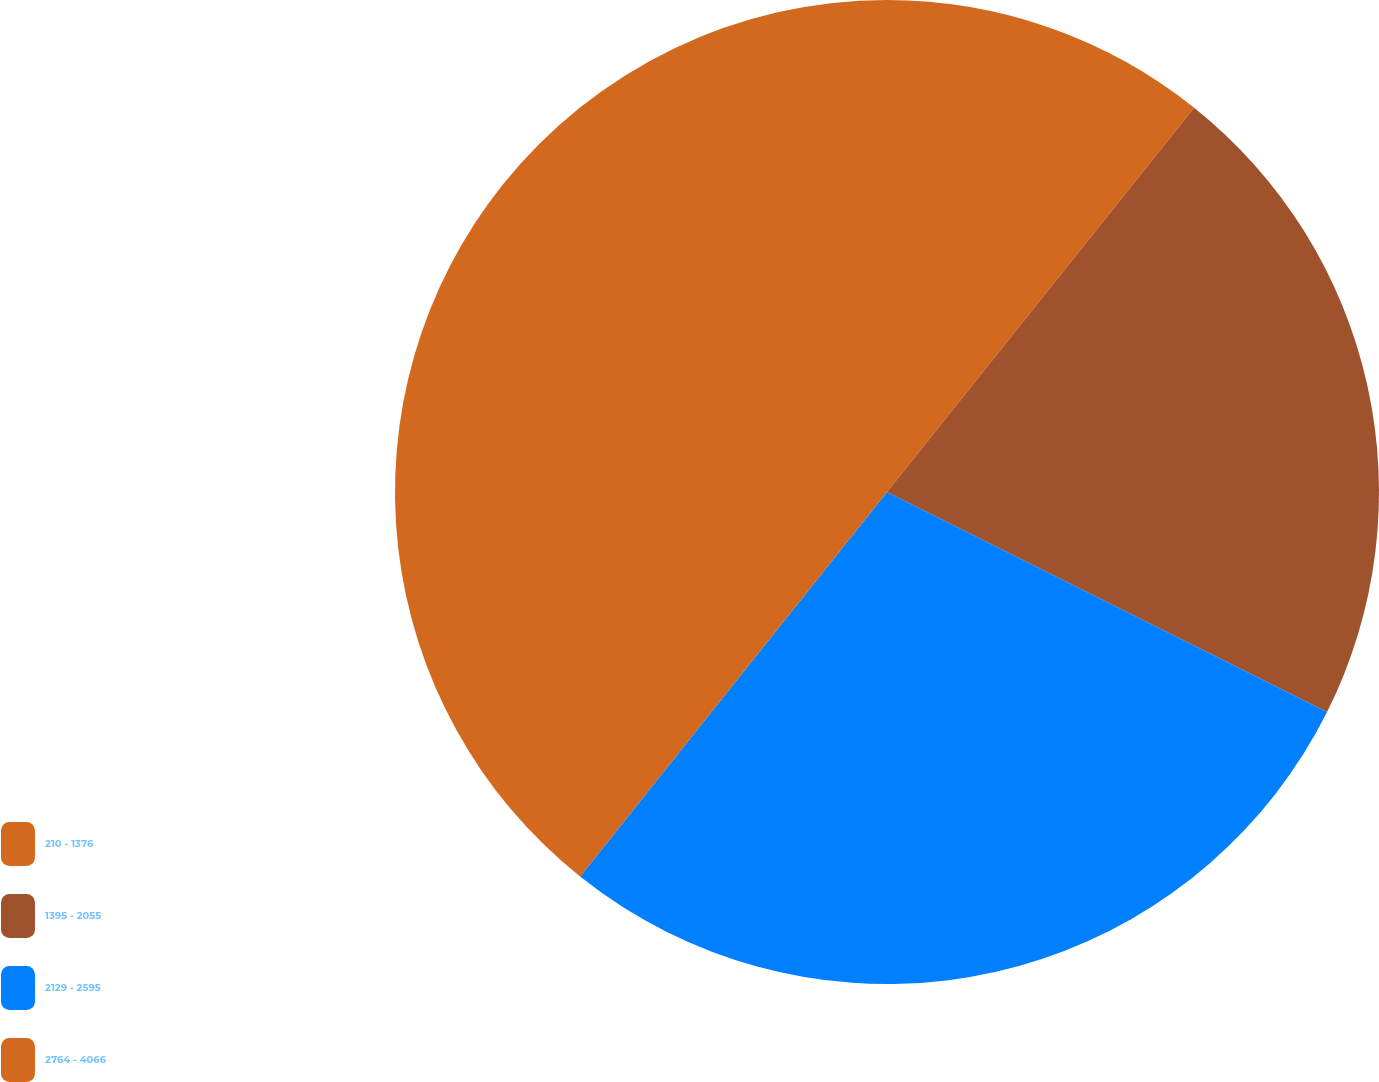Convert chart. <chart><loc_0><loc_0><loc_500><loc_500><pie_chart><fcel>210 - 1376<fcel>1395 - 2055<fcel>2129 - 2595<fcel>2764 - 4066<nl><fcel>10.73%<fcel>21.65%<fcel>28.34%<fcel>39.28%<nl></chart> 